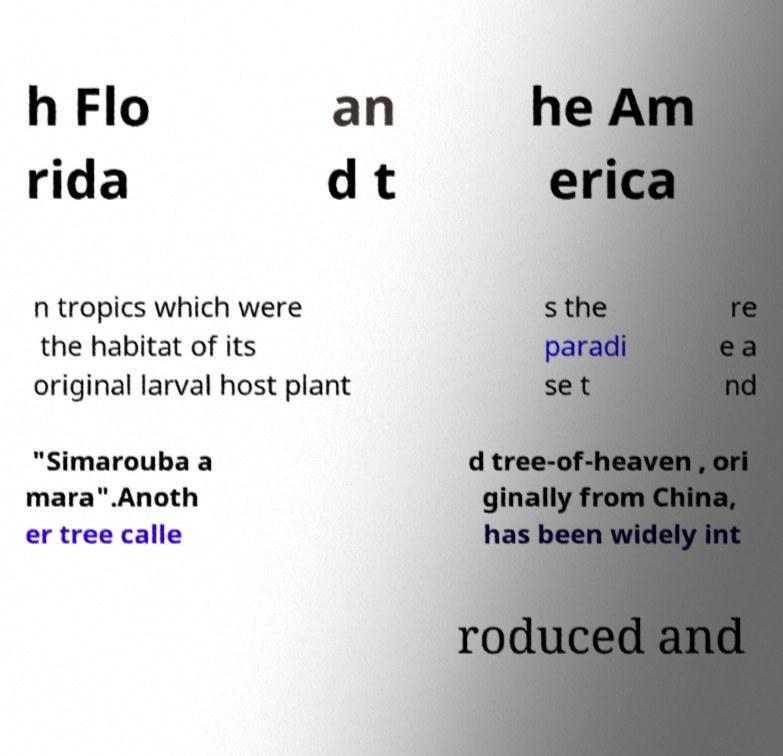I need the written content from this picture converted into text. Can you do that? h Flo rida an d t he Am erica n tropics which were the habitat of its original larval host plant s the paradi se t re e a nd "Simarouba a mara".Anoth er tree calle d tree-of-heaven , ori ginally from China, has been widely int roduced and 